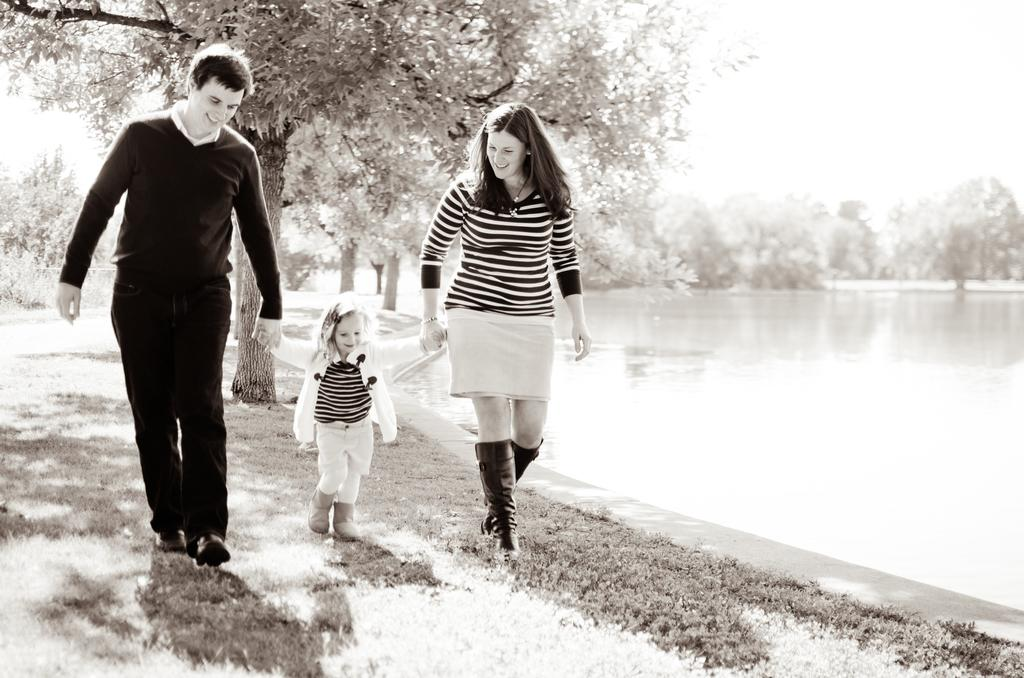How many people are present in the image? There are three people in the image: a man, a woman, and a girl. What are the people in the image doing? The people are walking on the ground in the image. What can be seen in the background of the image? There are trees, water, and the sky visible in the background of the image. What is the color scheme of the image? The image is black and white in color. What type of cheese can be seen hanging from the trees in the image? There is no cheese present in the image; it features a man, a woman, and a girl walking on the ground with trees, water, and the sky visible in the background. 